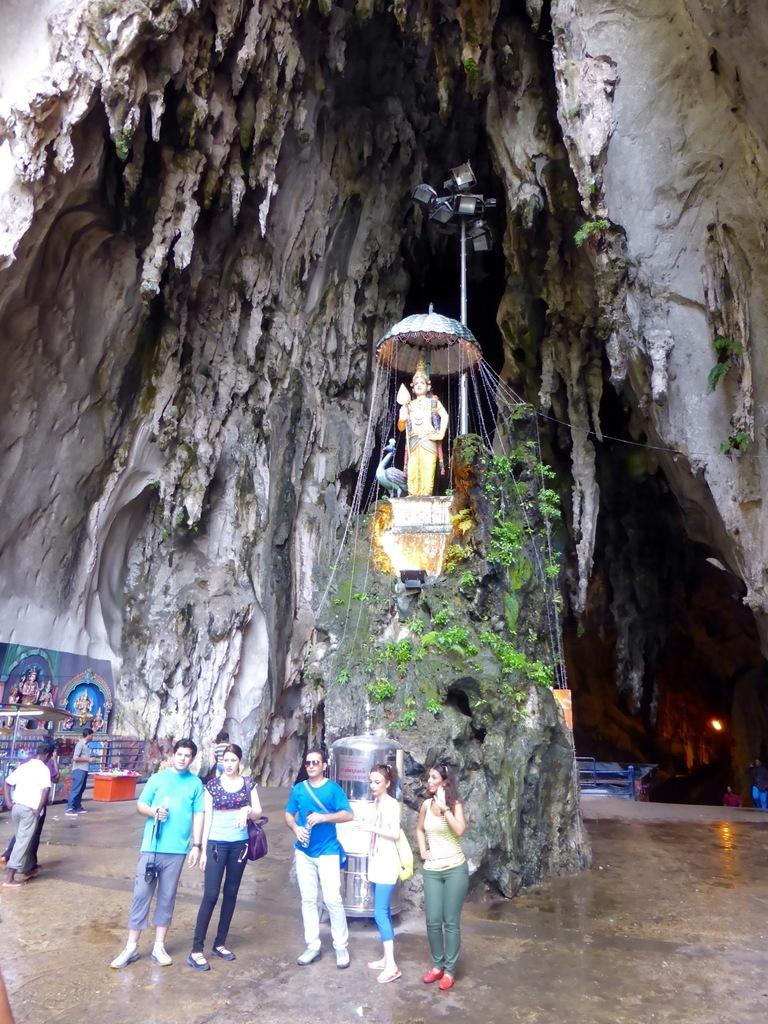How many people are present in the image? There are five persons standing in the image. What can be seen in the background of the image? There is a rock in the background of the image. What is on top of the rock? There is a statue on the rock. What is located above the rock and statue? There is a cave above the rock and statue. What type of cat can be seen climbing the statue in the image? There is no cat present in the image; it only features five persons, a rock, a statue, and a cave. 